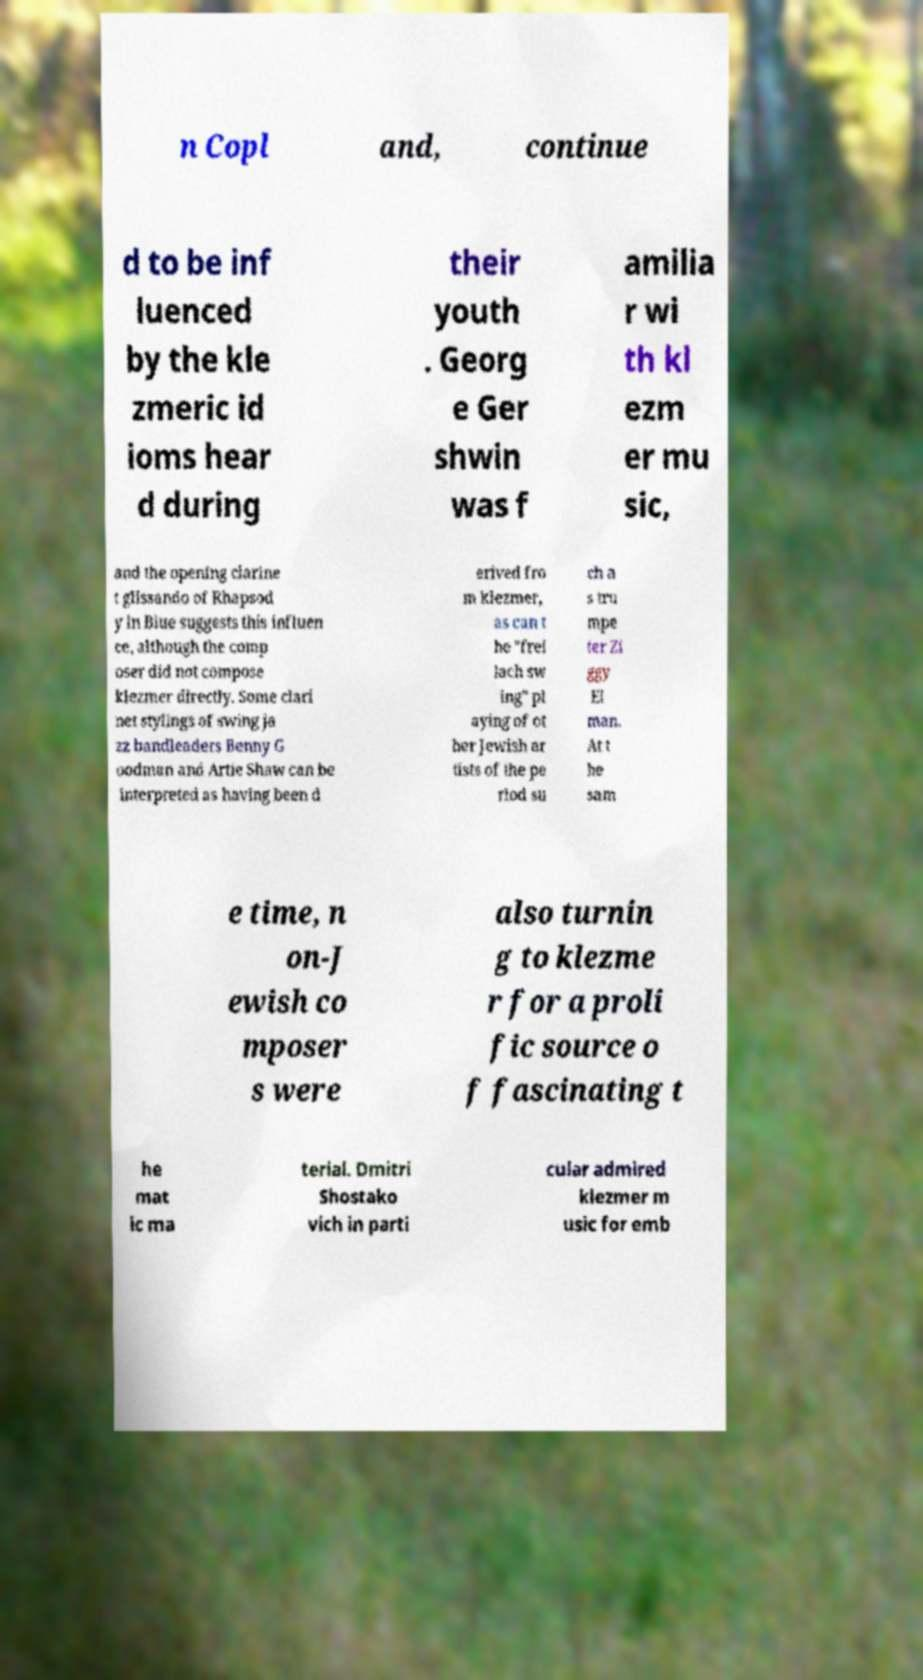Please identify and transcribe the text found in this image. n Copl and, continue d to be inf luenced by the kle zmeric id ioms hear d during their youth . Georg e Ger shwin was f amilia r wi th kl ezm er mu sic, and the opening clarine t glissando of Rhapsod y in Blue suggests this influen ce, although the comp oser did not compose klezmer directly. Some clari net stylings of swing ja zz bandleaders Benny G oodman and Artie Shaw can be interpreted as having been d erived fro m klezmer, as can t he "frei lach sw ing" pl aying of ot her Jewish ar tists of the pe riod su ch a s tru mpe ter Zi ggy El man. At t he sam e time, n on-J ewish co mposer s were also turnin g to klezme r for a proli fic source o f fascinating t he mat ic ma terial. Dmitri Shostako vich in parti cular admired klezmer m usic for emb 